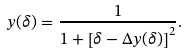<formula> <loc_0><loc_0><loc_500><loc_500>y ( \delta ) = \frac { 1 } { 1 + \left [ \delta - \Delta y ( \delta ) \right ] ^ { 2 } } .</formula> 